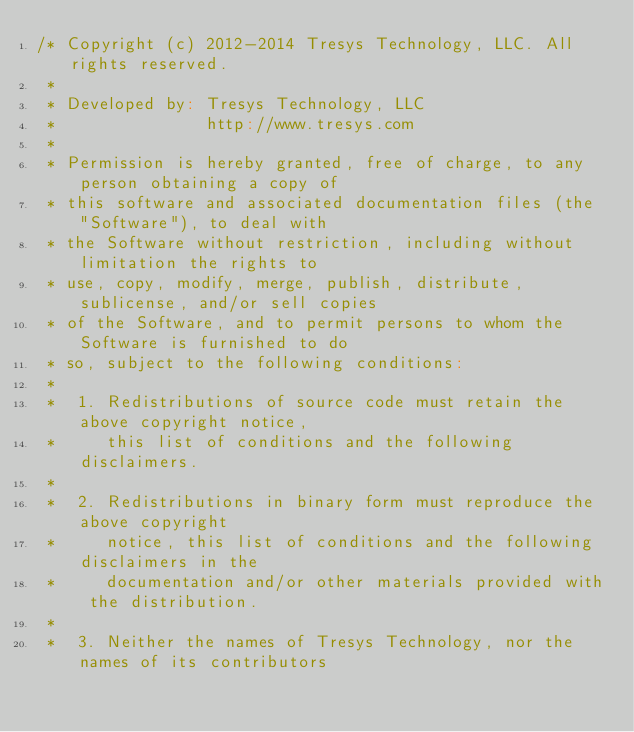Convert code to text. <code><loc_0><loc_0><loc_500><loc_500><_Scala_>/* Copyright (c) 2012-2014 Tresys Technology, LLC. All rights reserved.
 *
 * Developed by: Tresys Technology, LLC
 *               http://www.tresys.com
 *
 * Permission is hereby granted, free of charge, to any person obtaining a copy of
 * this software and associated documentation files (the "Software"), to deal with
 * the Software without restriction, including without limitation the rights to
 * use, copy, modify, merge, publish, distribute, sublicense, and/or sell copies
 * of the Software, and to permit persons to whom the Software is furnished to do
 * so, subject to the following conditions:
 *
 *  1. Redistributions of source code must retain the above copyright notice,
 *     this list of conditions and the following disclaimers.
 *
 *  2. Redistributions in binary form must reproduce the above copyright
 *     notice, this list of conditions and the following disclaimers in the
 *     documentation and/or other materials provided with the distribution.
 *
 *  3. Neither the names of Tresys Technology, nor the names of its contributors</code> 